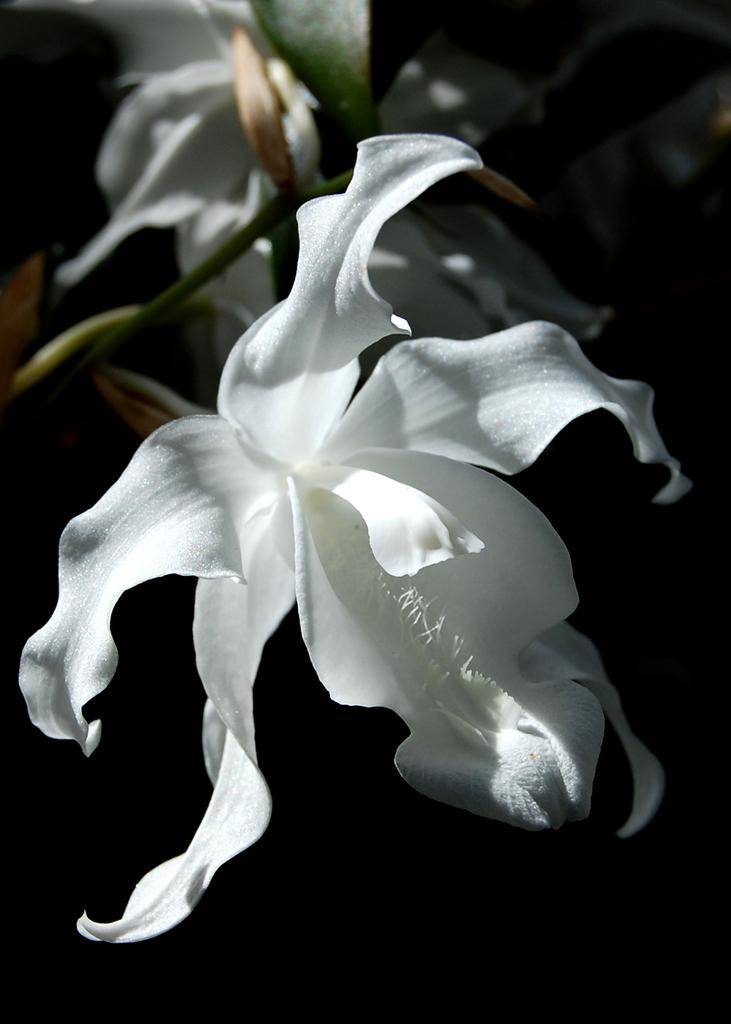What is located in the center of the image? There are leaves in the center of the image. What type of flowers can be seen in the image? There are white flowers in the image. Can you see any fangs on the leaves in the image? There are no fangs present on the leaves in the image, as leaves do not have fangs. What country is depicted in the image? The image does not depict a country; it features leaves and white flowers. 